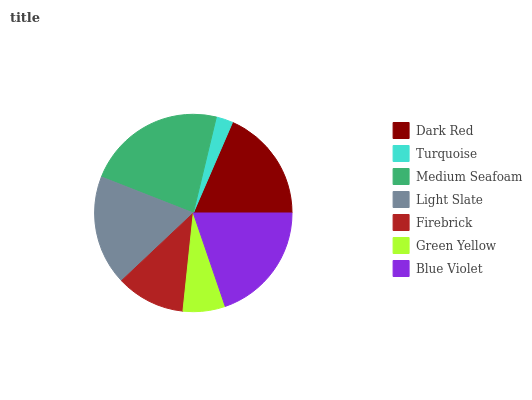Is Turquoise the minimum?
Answer yes or no. Yes. Is Medium Seafoam the maximum?
Answer yes or no. Yes. Is Medium Seafoam the minimum?
Answer yes or no. No. Is Turquoise the maximum?
Answer yes or no. No. Is Medium Seafoam greater than Turquoise?
Answer yes or no. Yes. Is Turquoise less than Medium Seafoam?
Answer yes or no. Yes. Is Turquoise greater than Medium Seafoam?
Answer yes or no. No. Is Medium Seafoam less than Turquoise?
Answer yes or no. No. Is Light Slate the high median?
Answer yes or no. Yes. Is Light Slate the low median?
Answer yes or no. Yes. Is Green Yellow the high median?
Answer yes or no. No. Is Dark Red the low median?
Answer yes or no. No. 